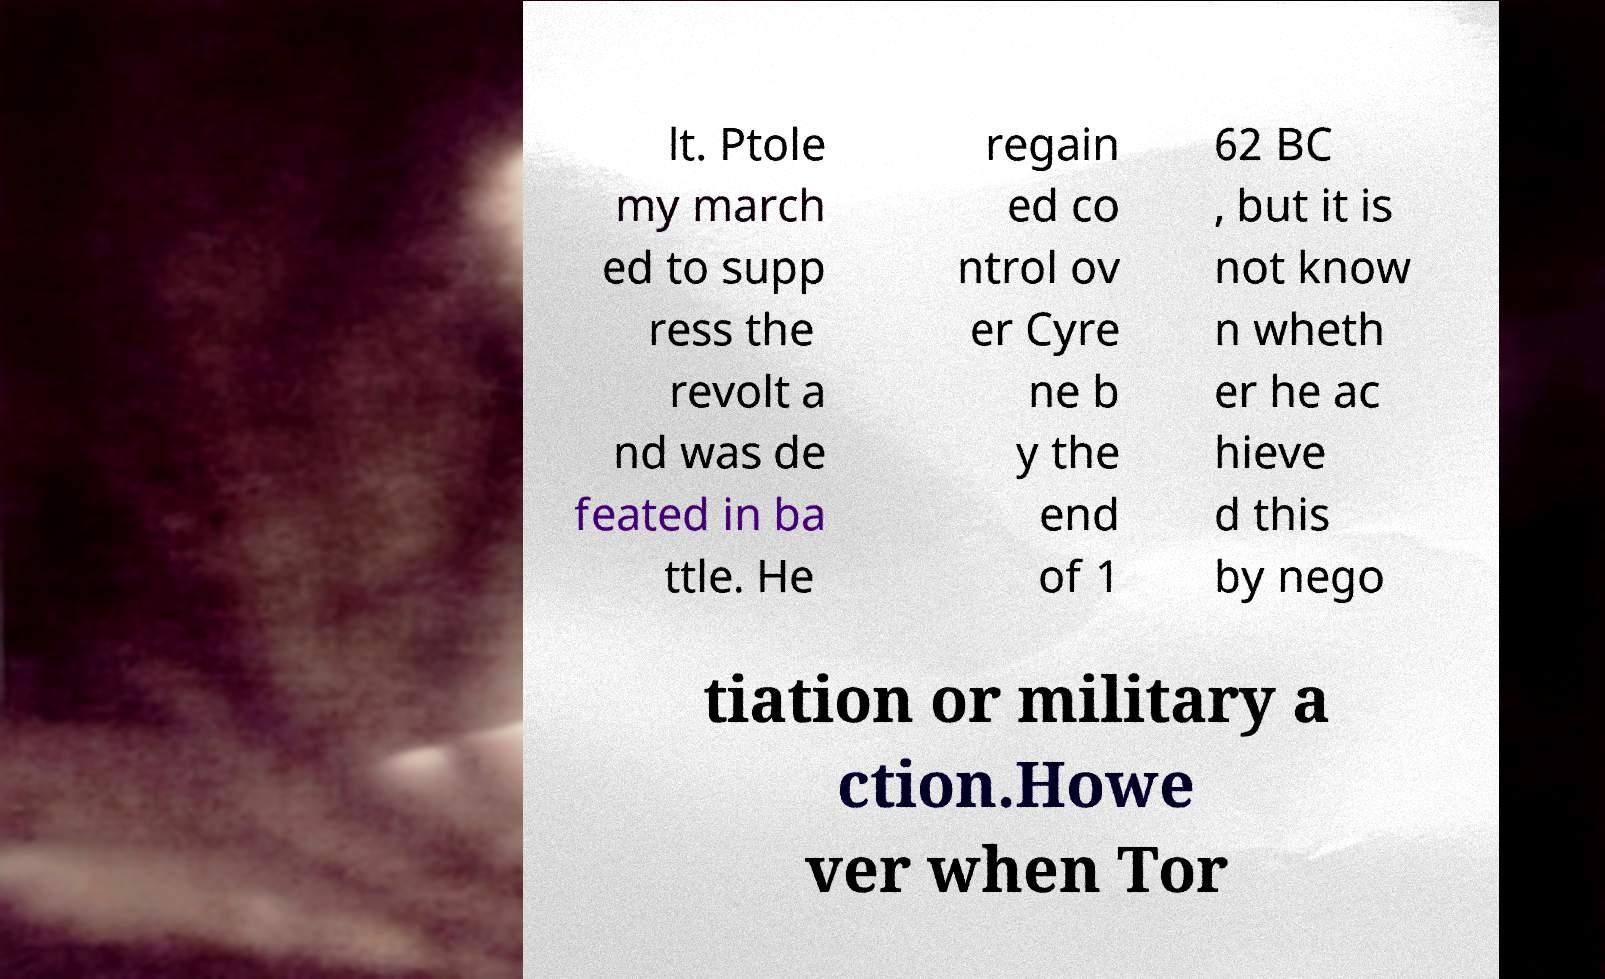Please identify and transcribe the text found in this image. lt. Ptole my march ed to supp ress the revolt a nd was de feated in ba ttle. He regain ed co ntrol ov er Cyre ne b y the end of 1 62 BC , but it is not know n wheth er he ac hieve d this by nego tiation or military a ction.Howe ver when Tor 